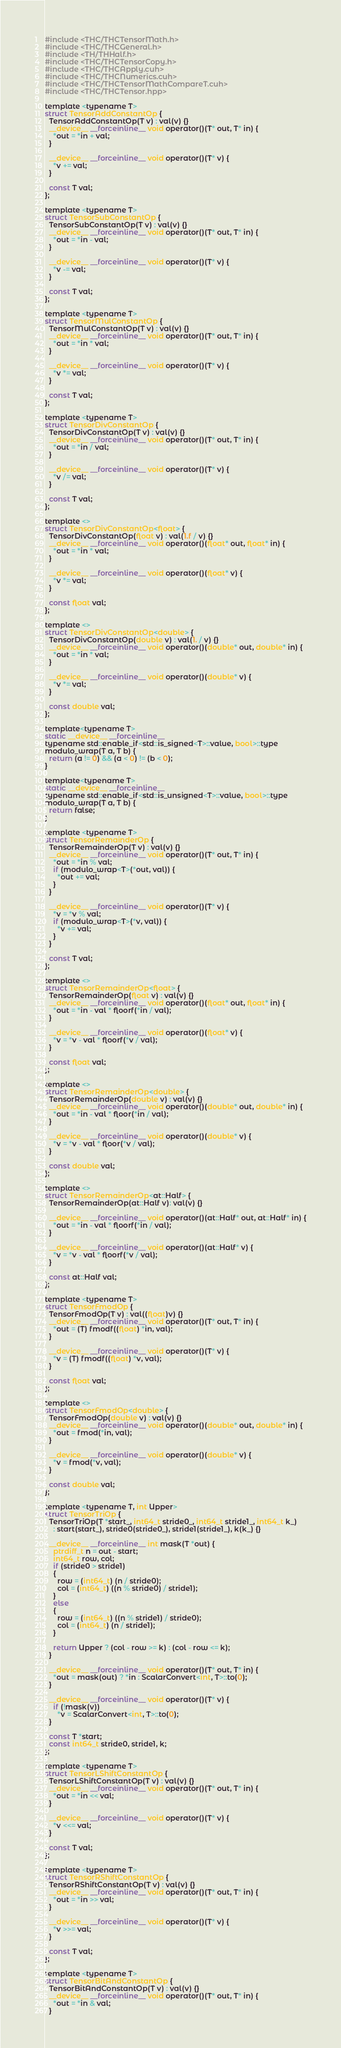<code> <loc_0><loc_0><loc_500><loc_500><_Cuda_>#include <THC/THCTensorMath.h>
#include <THC/THCGeneral.h>
#include <TH/THHalf.h>
#include <THC/THCTensorCopy.h>
#include <THC/THCApply.cuh>
#include <THC/THCNumerics.cuh>
#include <THC/THCTensorMathCompareT.cuh>
#include <THC/THCTensor.hpp>

template <typename T>
struct TensorAddConstantOp {
  TensorAddConstantOp(T v) : val(v) {}
  __device__ __forceinline__ void operator()(T* out, T* in) {
    *out = *in + val;
  }

  __device__ __forceinline__ void operator()(T* v) {
    *v += val;
  }

  const T val;
};

template <typename T>
struct TensorSubConstantOp {
  TensorSubConstantOp(T v) : val(v) {}
  __device__ __forceinline__ void operator()(T* out, T* in) {
    *out = *in - val;
  }

  __device__ __forceinline__ void operator()(T* v) {
    *v -= val;
  }

  const T val;
};

template <typename T>
struct TensorMulConstantOp {
  TensorMulConstantOp(T v) : val(v) {}
  __device__ __forceinline__ void operator()(T* out, T* in) {
    *out = *in * val;
  }

  __device__ __forceinline__ void operator()(T* v) {
    *v *= val;
  }

  const T val;
};

template <typename T>
struct TensorDivConstantOp {
  TensorDivConstantOp(T v) : val(v) {}
  __device__ __forceinline__ void operator()(T* out, T* in) {
    *out = *in / val;
  }

  __device__ __forceinline__ void operator()(T* v) {
    *v /= val;
  }

  const T val;
};

template <>
struct TensorDivConstantOp<float> {
  TensorDivConstantOp(float v) : val(1.f / v) {}
  __device__ __forceinline__ void operator()(float* out, float* in) {
    *out = *in * val;
  }

  __device__ __forceinline__ void operator()(float* v) {
    *v *= val;
  }

  const float val;
};

template <>
struct TensorDivConstantOp<double> {
  TensorDivConstantOp(double v) : val(1. / v) {}
  __device__ __forceinline__ void operator()(double* out, double* in) {
    *out = *in * val;
  }

  __device__ __forceinline__ void operator()(double* v) {
    *v *= val;
  }

  const double val;
};

template<typename T>
static __device__ __forceinline__
typename std::enable_if<std::is_signed<T>::value, bool>::type
modulo_wrap(T a, T b) {
  return (a != 0) && (a < 0) != (b < 0);
}

template<typename T>
static __device__ __forceinline__
typename std::enable_if<std::is_unsigned<T>::value, bool>::type
modulo_wrap(T a, T b) {
  return false;
}

template <typename T>
struct TensorRemainderOp {
  TensorRemainderOp(T v) : val(v) {}
  __device__ __forceinline__ void operator()(T* out, T* in) {
    *out = *in % val;
    if (modulo_wrap<T>(*out, val)) {
      *out += val;
    }
  }

  __device__ __forceinline__ void operator()(T* v) {
    *v = *v % val;
    if (modulo_wrap<T>(*v, val)) {
      *v += val;
    }
  }

  const T val;
};

template <>
struct TensorRemainderOp<float> {
  TensorRemainderOp(float v) : val(v) {}
  __device__ __forceinline__ void operator()(float* out, float* in) {
    *out = *in - val * floorf(*in / val);
  }

  __device__ __forceinline__ void operator()(float* v) {
    *v = *v - val * floorf(*v / val);
  }

  const float val;
};

template <>
struct TensorRemainderOp<double> {
  TensorRemainderOp(double v) : val(v) {}
  __device__ __forceinline__ void operator()(double* out, double* in) {
    *out = *in - val * floor(*in / val);
  }

  __device__ __forceinline__ void operator()(double* v) {
    *v = *v - val * floor(*v / val);
  }

  const double val;
};

template <>
struct TensorRemainderOp<at::Half> {
  TensorRemainderOp(at::Half v): val(v) {}

  __device__ __forceinline__ void operator()(at::Half* out, at::Half* in) {
    *out = *in - val * floorf(*in / val);
  }

  __device__ __forceinline__ void operator()(at::Half* v) {
    *v = *v - val * floorf(*v / val);
  }

  const at::Half val;
};

template <typename T>
struct TensorFmodOp {
  TensorFmodOp(T v) : val((float)v) {}
  __device__ __forceinline__ void operator()(T* out, T* in) {
    *out = (T) fmodf((float) *in, val);
  }

  __device__ __forceinline__ void operator()(T* v) {
    *v = (T) fmodf((float) *v, val);
  }

  const float val;
};

template <>
struct TensorFmodOp<double> {
  TensorFmodOp(double v) : val(v) {}
  __device__ __forceinline__ void operator()(double* out, double* in) {
    *out = fmod(*in, val);
  }

  __device__ __forceinline__ void operator()(double* v) {
    *v = fmod(*v, val);
  }

  const double val;
};

template <typename T, int Upper>
struct TensorTriOp {
  TensorTriOp(T *start_, int64_t stride0_, int64_t stride1_, int64_t k_)
    : start(start_), stride0(stride0_), stride1(stride1_), k(k_) {}

  __device__ __forceinline__ int mask(T *out) {
    ptrdiff_t n = out - start;
    int64_t row, col;
    if (stride0 > stride1)
    {
      row = (int64_t) (n / stride0);
      col = (int64_t) ((n % stride0) / stride1);
    }
    else
    {
      row = (int64_t) ((n % stride1) / stride0);
      col = (int64_t) (n / stride1);
    }

    return Upper ? (col - row >= k) : (col - row <= k);
  }

  __device__ __forceinline__ void operator()(T* out, T* in) {
    *out = mask(out) ? *in : ScalarConvert<int, T>::to(0);
  }

  __device__ __forceinline__ void operator()(T* v) {
    if (!mask(v))
      *v = ScalarConvert<int, T>::to(0);
  }

  const T *start;
  const int64_t stride0, stride1, k;
};

template <typename T>
struct TensorLShiftConstantOp {
  TensorLShiftConstantOp(T v) : val(v) {}
  __device__ __forceinline__ void operator()(T* out, T* in) {
    *out = *in << val;
  }

  __device__ __forceinline__ void operator()(T* v) {
    *v <<= val;
  }

  const T val;
};

template <typename T>
struct TensorRShiftConstantOp {
  TensorRShiftConstantOp(T v) : val(v) {}
  __device__ __forceinline__ void operator()(T* out, T* in) {
    *out = *in >> val;
  }

  __device__ __forceinline__ void operator()(T* v) {
    *v >>= val;
  }

  const T val;
};

template <typename T>
struct TensorBitAndConstantOp {
  TensorBitAndConstantOp(T v) : val(v) {}
  __device__ __forceinline__ void operator()(T* out, T* in) {
    *out = *in & val;
  }
</code> 